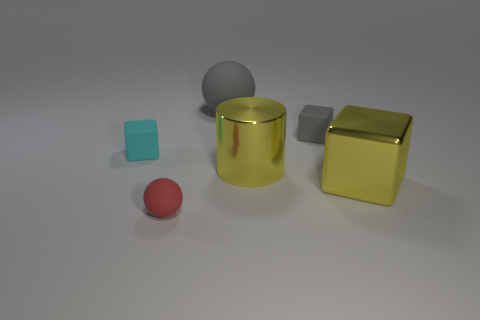What shape is the big yellow object that is the same material as the large block?
Keep it short and to the point. Cylinder. Does the gray rubber sphere have the same size as the yellow block?
Your answer should be very brief. Yes. Do the object that is to the left of the red rubber object and the small sphere have the same material?
Offer a terse response. Yes. Is there any other thing that is the same material as the big gray ball?
Make the answer very short. Yes. What number of big gray spheres are on the left side of the big thing behind the gray object that is on the right side of the gray ball?
Provide a succinct answer. 0. There is a yellow thing on the right side of the gray cube; is its shape the same as the tiny red thing?
Offer a terse response. No. How many objects are either tiny gray matte blocks or matte cubes that are right of the gray sphere?
Keep it short and to the point. 1. Is the number of tiny cyan matte things that are to the left of the cyan matte cube greater than the number of small red shiny blocks?
Make the answer very short. No. Are there the same number of big yellow cylinders that are behind the big cube and yellow objects behind the tiny gray matte thing?
Your answer should be compact. No. Is there a large sphere that is to the right of the matte block that is behind the cyan matte block?
Provide a succinct answer. No. 